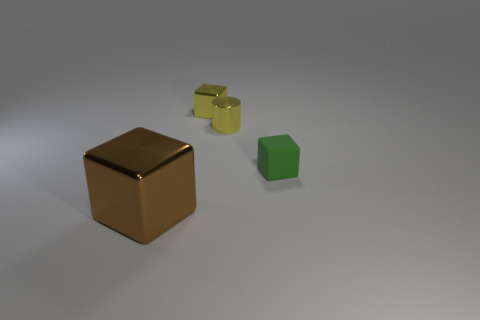Is there anything else that is the same size as the brown shiny block?
Give a very brief answer. No. What is the color of the cylinder that is the same material as the large brown block?
Provide a short and direct response. Yellow. Are there fewer green things that are in front of the big brown cube than yellow things right of the small yellow metallic block?
Your answer should be compact. Yes. How many small shiny cubes are the same color as the small metal cylinder?
Provide a succinct answer. 1. What number of objects are both behind the small green matte thing and on the right side of the yellow block?
Ensure brevity in your answer.  1. There is a green object in front of the small yellow shiny object that is right of the yellow cube; what is its material?
Your answer should be compact. Rubber. Are there any brown things made of the same material as the tiny cylinder?
Your response must be concise. Yes. What is the material of the green block that is the same size as the yellow cylinder?
Your answer should be compact. Rubber. What size is the green cube that is right of the shiny cube behind the thing that is in front of the green matte cube?
Make the answer very short. Small. Is there a object that is to the left of the rubber cube that is in front of the tiny yellow cylinder?
Keep it short and to the point. Yes. 